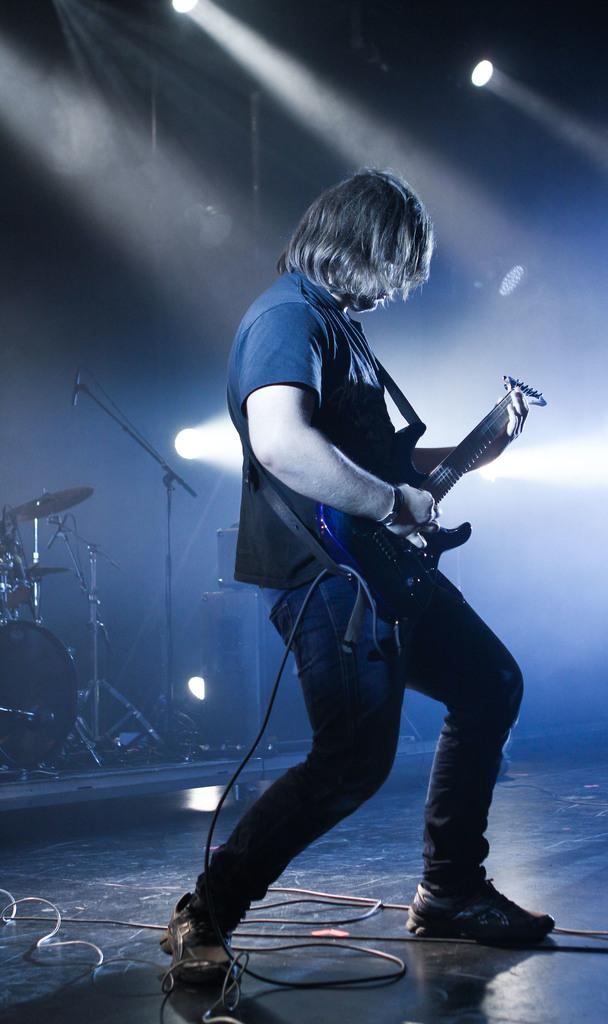What is the main subject of the image? There is a person standing on the stage. What is the person on the stage doing? The person is playing a musical instrument. Are there any other musical instruments visible in the image? Yes, there are other musical instruments visible in the image. How many dinosaurs can be seen playing musical instruments in the image? There are no dinosaurs present in the image, and therefore no dinosaurs playing musical instruments can be observed. 